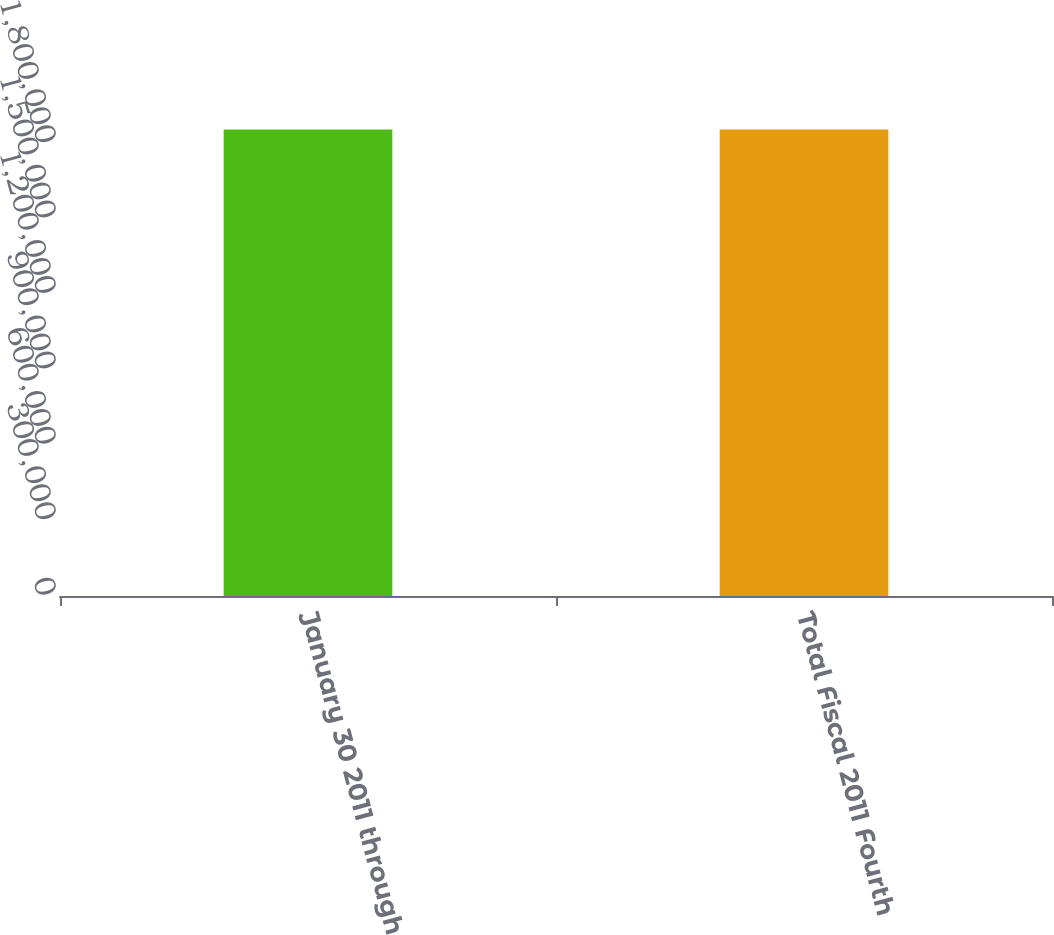<chart> <loc_0><loc_0><loc_500><loc_500><bar_chart><fcel>January 30 2011 through<fcel>Total Fiscal 2011 Fourth<nl><fcel>1.85574e+06<fcel>1.85574e+06<nl></chart> 